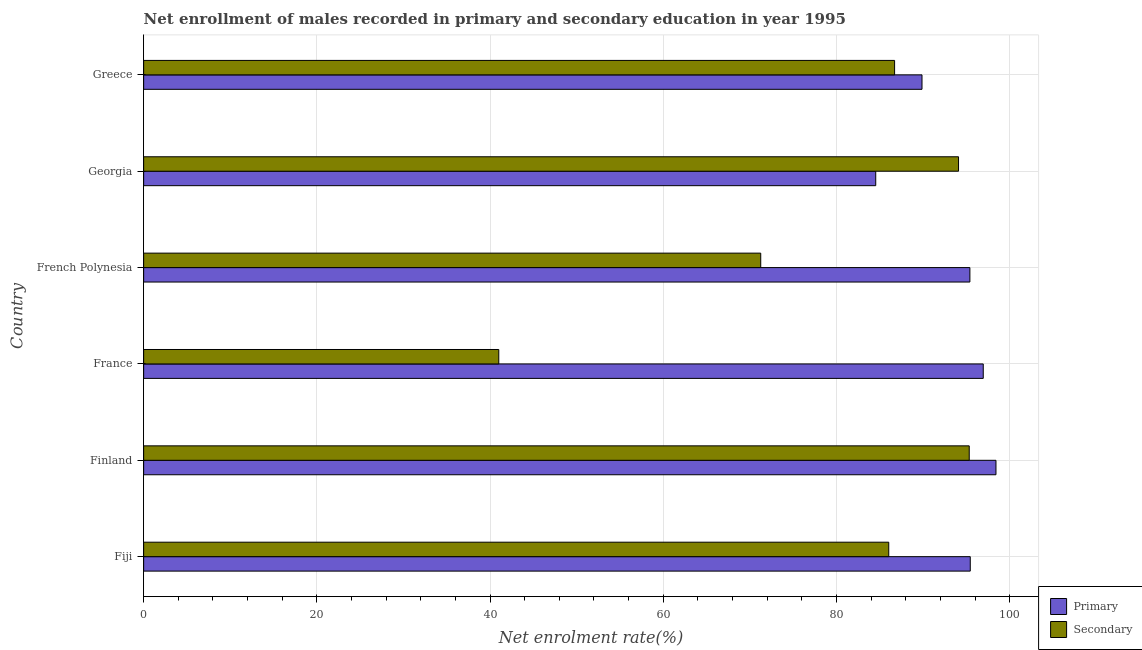Are the number of bars per tick equal to the number of legend labels?
Your answer should be very brief. Yes. How many bars are there on the 4th tick from the top?
Provide a succinct answer. 2. How many bars are there on the 2nd tick from the bottom?
Give a very brief answer. 2. What is the label of the 1st group of bars from the top?
Your response must be concise. Greece. What is the enrollment rate in primary education in Greece?
Your answer should be very brief. 89.88. Across all countries, what is the maximum enrollment rate in primary education?
Make the answer very short. 98.42. Across all countries, what is the minimum enrollment rate in secondary education?
Offer a very short reply. 41.01. In which country was the enrollment rate in secondary education maximum?
Keep it short and to the point. Finland. In which country was the enrollment rate in primary education minimum?
Your answer should be very brief. Georgia. What is the total enrollment rate in secondary education in the graph?
Keep it short and to the point. 474.45. What is the difference between the enrollment rate in secondary education in France and that in Georgia?
Keep it short and to the point. -53.09. What is the difference between the enrollment rate in secondary education in Finland and the enrollment rate in primary education in French Polynesia?
Ensure brevity in your answer.  -0.08. What is the average enrollment rate in primary education per country?
Offer a very short reply. 93.44. What is the difference between the enrollment rate in primary education and enrollment rate in secondary education in French Polynesia?
Give a very brief answer. 24.15. In how many countries, is the enrollment rate in secondary education greater than 8 %?
Provide a short and direct response. 6. What is the ratio of the enrollment rate in primary education in Finland to that in French Polynesia?
Keep it short and to the point. 1.03. Is the difference between the enrollment rate in secondary education in France and Greece greater than the difference between the enrollment rate in primary education in France and Greece?
Keep it short and to the point. No. What is the difference between the highest and the second highest enrollment rate in secondary education?
Provide a succinct answer. 1.24. What is the difference between the highest and the lowest enrollment rate in primary education?
Provide a succinct answer. 13.88. Is the sum of the enrollment rate in secondary education in France and Greece greater than the maximum enrollment rate in primary education across all countries?
Offer a terse response. Yes. What does the 2nd bar from the top in Greece represents?
Your answer should be very brief. Primary. What does the 1st bar from the bottom in French Polynesia represents?
Your answer should be compact. Primary. What is the difference between two consecutive major ticks on the X-axis?
Offer a very short reply. 20. Are the values on the major ticks of X-axis written in scientific E-notation?
Provide a succinct answer. No. Does the graph contain any zero values?
Your answer should be very brief. No. Does the graph contain grids?
Your answer should be compact. Yes. How are the legend labels stacked?
Provide a short and direct response. Vertical. What is the title of the graph?
Offer a terse response. Net enrollment of males recorded in primary and secondary education in year 1995. What is the label or title of the X-axis?
Give a very brief answer. Net enrolment rate(%). What is the Net enrolment rate(%) of Primary in Fiji?
Your answer should be very brief. 95.45. What is the Net enrolment rate(%) of Secondary in Fiji?
Your answer should be very brief. 86.04. What is the Net enrolment rate(%) of Primary in Finland?
Offer a terse response. 98.42. What is the Net enrolment rate(%) in Secondary in Finland?
Provide a succinct answer. 95.33. What is the Net enrolment rate(%) in Primary in France?
Your answer should be compact. 96.95. What is the Net enrolment rate(%) of Secondary in France?
Provide a short and direct response. 41.01. What is the Net enrolment rate(%) of Primary in French Polynesia?
Your response must be concise. 95.41. What is the Net enrolment rate(%) of Secondary in French Polynesia?
Your response must be concise. 71.26. What is the Net enrolment rate(%) in Primary in Georgia?
Keep it short and to the point. 84.54. What is the Net enrolment rate(%) in Secondary in Georgia?
Provide a short and direct response. 94.1. What is the Net enrolment rate(%) in Primary in Greece?
Give a very brief answer. 89.88. What is the Net enrolment rate(%) of Secondary in Greece?
Your answer should be compact. 86.71. Across all countries, what is the maximum Net enrolment rate(%) of Primary?
Keep it short and to the point. 98.42. Across all countries, what is the maximum Net enrolment rate(%) in Secondary?
Ensure brevity in your answer.  95.33. Across all countries, what is the minimum Net enrolment rate(%) of Primary?
Give a very brief answer. 84.54. Across all countries, what is the minimum Net enrolment rate(%) of Secondary?
Provide a succinct answer. 41.01. What is the total Net enrolment rate(%) in Primary in the graph?
Give a very brief answer. 560.65. What is the total Net enrolment rate(%) of Secondary in the graph?
Keep it short and to the point. 474.45. What is the difference between the Net enrolment rate(%) in Primary in Fiji and that in Finland?
Keep it short and to the point. -2.97. What is the difference between the Net enrolment rate(%) of Secondary in Fiji and that in Finland?
Ensure brevity in your answer.  -9.29. What is the difference between the Net enrolment rate(%) of Primary in Fiji and that in France?
Your answer should be compact. -1.5. What is the difference between the Net enrolment rate(%) in Secondary in Fiji and that in France?
Your answer should be very brief. 45.03. What is the difference between the Net enrolment rate(%) of Primary in Fiji and that in French Polynesia?
Give a very brief answer. 0.04. What is the difference between the Net enrolment rate(%) in Secondary in Fiji and that in French Polynesia?
Provide a short and direct response. 14.78. What is the difference between the Net enrolment rate(%) of Primary in Fiji and that in Georgia?
Give a very brief answer. 10.91. What is the difference between the Net enrolment rate(%) in Secondary in Fiji and that in Georgia?
Offer a very short reply. -8.06. What is the difference between the Net enrolment rate(%) in Primary in Fiji and that in Greece?
Provide a short and direct response. 5.57. What is the difference between the Net enrolment rate(%) of Secondary in Fiji and that in Greece?
Make the answer very short. -0.67. What is the difference between the Net enrolment rate(%) of Primary in Finland and that in France?
Provide a short and direct response. 1.47. What is the difference between the Net enrolment rate(%) in Secondary in Finland and that in France?
Provide a succinct answer. 54.33. What is the difference between the Net enrolment rate(%) of Primary in Finland and that in French Polynesia?
Keep it short and to the point. 3.01. What is the difference between the Net enrolment rate(%) in Secondary in Finland and that in French Polynesia?
Your response must be concise. 24.08. What is the difference between the Net enrolment rate(%) of Primary in Finland and that in Georgia?
Your answer should be very brief. 13.88. What is the difference between the Net enrolment rate(%) of Secondary in Finland and that in Georgia?
Give a very brief answer. 1.24. What is the difference between the Net enrolment rate(%) of Primary in Finland and that in Greece?
Offer a very short reply. 8.54. What is the difference between the Net enrolment rate(%) in Secondary in Finland and that in Greece?
Make the answer very short. 8.62. What is the difference between the Net enrolment rate(%) of Primary in France and that in French Polynesia?
Provide a short and direct response. 1.54. What is the difference between the Net enrolment rate(%) in Secondary in France and that in French Polynesia?
Provide a succinct answer. -30.25. What is the difference between the Net enrolment rate(%) of Primary in France and that in Georgia?
Your answer should be compact. 12.41. What is the difference between the Net enrolment rate(%) of Secondary in France and that in Georgia?
Ensure brevity in your answer.  -53.09. What is the difference between the Net enrolment rate(%) in Primary in France and that in Greece?
Your response must be concise. 7.07. What is the difference between the Net enrolment rate(%) in Secondary in France and that in Greece?
Ensure brevity in your answer.  -45.71. What is the difference between the Net enrolment rate(%) in Primary in French Polynesia and that in Georgia?
Ensure brevity in your answer.  10.87. What is the difference between the Net enrolment rate(%) in Secondary in French Polynesia and that in Georgia?
Your answer should be compact. -22.84. What is the difference between the Net enrolment rate(%) in Primary in French Polynesia and that in Greece?
Ensure brevity in your answer.  5.53. What is the difference between the Net enrolment rate(%) of Secondary in French Polynesia and that in Greece?
Your answer should be compact. -15.46. What is the difference between the Net enrolment rate(%) in Primary in Georgia and that in Greece?
Your answer should be compact. -5.34. What is the difference between the Net enrolment rate(%) of Secondary in Georgia and that in Greece?
Ensure brevity in your answer.  7.38. What is the difference between the Net enrolment rate(%) of Primary in Fiji and the Net enrolment rate(%) of Secondary in Finland?
Offer a very short reply. 0.12. What is the difference between the Net enrolment rate(%) in Primary in Fiji and the Net enrolment rate(%) in Secondary in France?
Your response must be concise. 54.44. What is the difference between the Net enrolment rate(%) of Primary in Fiji and the Net enrolment rate(%) of Secondary in French Polynesia?
Make the answer very short. 24.19. What is the difference between the Net enrolment rate(%) of Primary in Fiji and the Net enrolment rate(%) of Secondary in Georgia?
Your response must be concise. 1.35. What is the difference between the Net enrolment rate(%) in Primary in Fiji and the Net enrolment rate(%) in Secondary in Greece?
Your response must be concise. 8.74. What is the difference between the Net enrolment rate(%) in Primary in Finland and the Net enrolment rate(%) in Secondary in France?
Offer a very short reply. 57.41. What is the difference between the Net enrolment rate(%) of Primary in Finland and the Net enrolment rate(%) of Secondary in French Polynesia?
Give a very brief answer. 27.16. What is the difference between the Net enrolment rate(%) in Primary in Finland and the Net enrolment rate(%) in Secondary in Georgia?
Make the answer very short. 4.32. What is the difference between the Net enrolment rate(%) in Primary in Finland and the Net enrolment rate(%) in Secondary in Greece?
Your response must be concise. 11.71. What is the difference between the Net enrolment rate(%) of Primary in France and the Net enrolment rate(%) of Secondary in French Polynesia?
Ensure brevity in your answer.  25.69. What is the difference between the Net enrolment rate(%) of Primary in France and the Net enrolment rate(%) of Secondary in Georgia?
Provide a succinct answer. 2.86. What is the difference between the Net enrolment rate(%) of Primary in France and the Net enrolment rate(%) of Secondary in Greece?
Make the answer very short. 10.24. What is the difference between the Net enrolment rate(%) in Primary in French Polynesia and the Net enrolment rate(%) in Secondary in Georgia?
Ensure brevity in your answer.  1.31. What is the difference between the Net enrolment rate(%) of Primary in French Polynesia and the Net enrolment rate(%) of Secondary in Greece?
Keep it short and to the point. 8.69. What is the difference between the Net enrolment rate(%) in Primary in Georgia and the Net enrolment rate(%) in Secondary in Greece?
Ensure brevity in your answer.  -2.18. What is the average Net enrolment rate(%) of Primary per country?
Keep it short and to the point. 93.44. What is the average Net enrolment rate(%) in Secondary per country?
Give a very brief answer. 79.07. What is the difference between the Net enrolment rate(%) of Primary and Net enrolment rate(%) of Secondary in Fiji?
Your answer should be very brief. 9.41. What is the difference between the Net enrolment rate(%) of Primary and Net enrolment rate(%) of Secondary in Finland?
Ensure brevity in your answer.  3.09. What is the difference between the Net enrolment rate(%) in Primary and Net enrolment rate(%) in Secondary in France?
Offer a terse response. 55.94. What is the difference between the Net enrolment rate(%) in Primary and Net enrolment rate(%) in Secondary in French Polynesia?
Ensure brevity in your answer.  24.15. What is the difference between the Net enrolment rate(%) in Primary and Net enrolment rate(%) in Secondary in Georgia?
Your response must be concise. -9.56. What is the difference between the Net enrolment rate(%) in Primary and Net enrolment rate(%) in Secondary in Greece?
Keep it short and to the point. 3.17. What is the ratio of the Net enrolment rate(%) in Primary in Fiji to that in Finland?
Your answer should be compact. 0.97. What is the ratio of the Net enrolment rate(%) in Secondary in Fiji to that in Finland?
Provide a succinct answer. 0.9. What is the ratio of the Net enrolment rate(%) in Primary in Fiji to that in France?
Your answer should be compact. 0.98. What is the ratio of the Net enrolment rate(%) in Secondary in Fiji to that in France?
Your answer should be very brief. 2.1. What is the ratio of the Net enrolment rate(%) in Secondary in Fiji to that in French Polynesia?
Ensure brevity in your answer.  1.21. What is the ratio of the Net enrolment rate(%) in Primary in Fiji to that in Georgia?
Provide a succinct answer. 1.13. What is the ratio of the Net enrolment rate(%) in Secondary in Fiji to that in Georgia?
Keep it short and to the point. 0.91. What is the ratio of the Net enrolment rate(%) of Primary in Fiji to that in Greece?
Your answer should be compact. 1.06. What is the ratio of the Net enrolment rate(%) of Primary in Finland to that in France?
Your answer should be very brief. 1.02. What is the ratio of the Net enrolment rate(%) in Secondary in Finland to that in France?
Your answer should be very brief. 2.32. What is the ratio of the Net enrolment rate(%) in Primary in Finland to that in French Polynesia?
Your response must be concise. 1.03. What is the ratio of the Net enrolment rate(%) in Secondary in Finland to that in French Polynesia?
Ensure brevity in your answer.  1.34. What is the ratio of the Net enrolment rate(%) in Primary in Finland to that in Georgia?
Ensure brevity in your answer.  1.16. What is the ratio of the Net enrolment rate(%) in Secondary in Finland to that in Georgia?
Give a very brief answer. 1.01. What is the ratio of the Net enrolment rate(%) of Primary in Finland to that in Greece?
Offer a terse response. 1.09. What is the ratio of the Net enrolment rate(%) in Secondary in Finland to that in Greece?
Offer a terse response. 1.1. What is the ratio of the Net enrolment rate(%) of Primary in France to that in French Polynesia?
Offer a very short reply. 1.02. What is the ratio of the Net enrolment rate(%) in Secondary in France to that in French Polynesia?
Your answer should be compact. 0.58. What is the ratio of the Net enrolment rate(%) in Primary in France to that in Georgia?
Keep it short and to the point. 1.15. What is the ratio of the Net enrolment rate(%) in Secondary in France to that in Georgia?
Your response must be concise. 0.44. What is the ratio of the Net enrolment rate(%) in Primary in France to that in Greece?
Ensure brevity in your answer.  1.08. What is the ratio of the Net enrolment rate(%) of Secondary in France to that in Greece?
Offer a very short reply. 0.47. What is the ratio of the Net enrolment rate(%) of Primary in French Polynesia to that in Georgia?
Your answer should be compact. 1.13. What is the ratio of the Net enrolment rate(%) of Secondary in French Polynesia to that in Georgia?
Offer a terse response. 0.76. What is the ratio of the Net enrolment rate(%) of Primary in French Polynesia to that in Greece?
Ensure brevity in your answer.  1.06. What is the ratio of the Net enrolment rate(%) in Secondary in French Polynesia to that in Greece?
Keep it short and to the point. 0.82. What is the ratio of the Net enrolment rate(%) of Primary in Georgia to that in Greece?
Your answer should be very brief. 0.94. What is the ratio of the Net enrolment rate(%) in Secondary in Georgia to that in Greece?
Your answer should be very brief. 1.09. What is the difference between the highest and the second highest Net enrolment rate(%) of Primary?
Keep it short and to the point. 1.47. What is the difference between the highest and the second highest Net enrolment rate(%) in Secondary?
Make the answer very short. 1.24. What is the difference between the highest and the lowest Net enrolment rate(%) in Primary?
Offer a very short reply. 13.88. What is the difference between the highest and the lowest Net enrolment rate(%) in Secondary?
Your response must be concise. 54.33. 